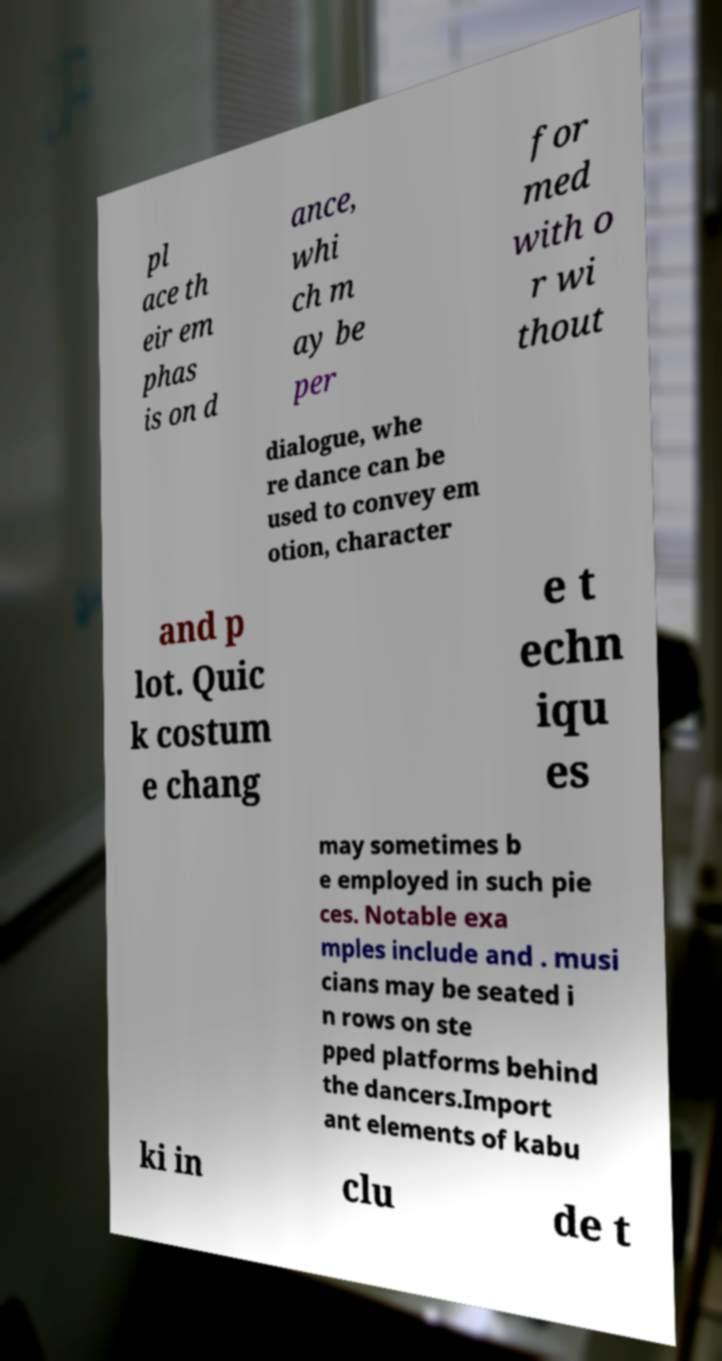Can you accurately transcribe the text from the provided image for me? pl ace th eir em phas is on d ance, whi ch m ay be per for med with o r wi thout dialogue, whe re dance can be used to convey em otion, character and p lot. Quic k costum e chang e t echn iqu es may sometimes b e employed in such pie ces. Notable exa mples include and . musi cians may be seated i n rows on ste pped platforms behind the dancers.Import ant elements of kabu ki in clu de t 